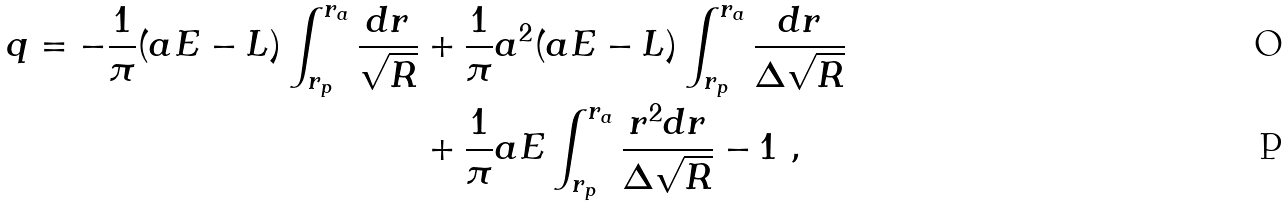<formula> <loc_0><loc_0><loc_500><loc_500>q = - \frac { 1 } { \pi } ( a E - L ) \int _ { r _ { p } } ^ { r _ { a } } \frac { d r } { \sqrt { R } } & + \frac { 1 } { \pi } a ^ { 2 } ( a E - L ) \int _ { r _ { p } } ^ { r _ { a } } \frac { d r } { \Delta \sqrt { R } } \\ & + \frac { 1 } { \pi } a E \int _ { r _ { p } } ^ { r _ { a } } \frac { r ^ { 2 } d r } { \Delta \sqrt { R } } - 1 \ ,</formula> 